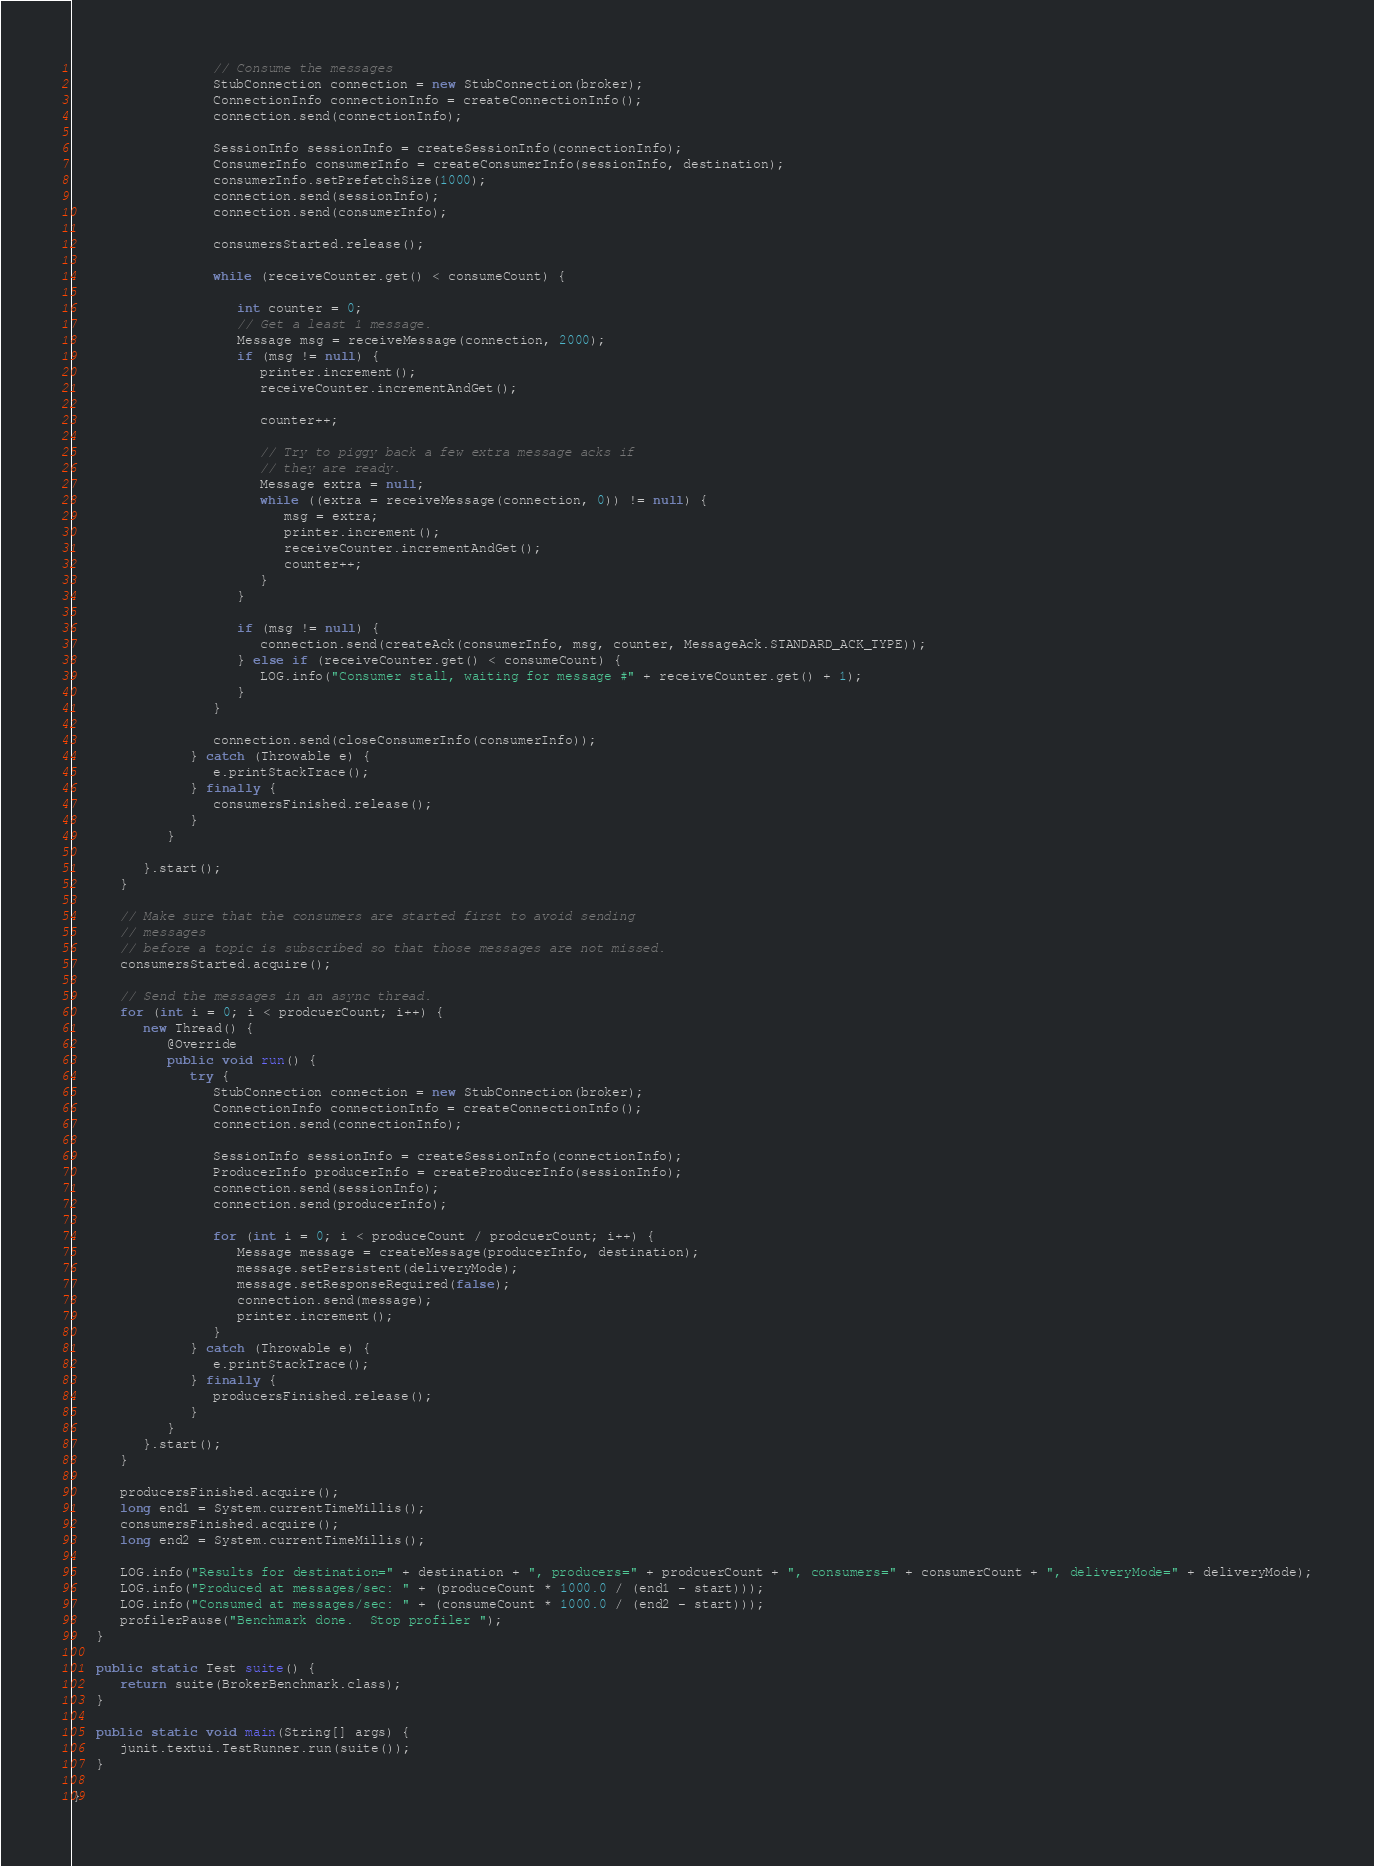<code> <loc_0><loc_0><loc_500><loc_500><_Java_>
                  // Consume the messages
                  StubConnection connection = new StubConnection(broker);
                  ConnectionInfo connectionInfo = createConnectionInfo();
                  connection.send(connectionInfo);

                  SessionInfo sessionInfo = createSessionInfo(connectionInfo);
                  ConsumerInfo consumerInfo = createConsumerInfo(sessionInfo, destination);
                  consumerInfo.setPrefetchSize(1000);
                  connection.send(sessionInfo);
                  connection.send(consumerInfo);

                  consumersStarted.release();

                  while (receiveCounter.get() < consumeCount) {

                     int counter = 0;
                     // Get a least 1 message.
                     Message msg = receiveMessage(connection, 2000);
                     if (msg != null) {
                        printer.increment();
                        receiveCounter.incrementAndGet();

                        counter++;

                        // Try to piggy back a few extra message acks if
                        // they are ready.
                        Message extra = null;
                        while ((extra = receiveMessage(connection, 0)) != null) {
                           msg = extra;
                           printer.increment();
                           receiveCounter.incrementAndGet();
                           counter++;
                        }
                     }

                     if (msg != null) {
                        connection.send(createAck(consumerInfo, msg, counter, MessageAck.STANDARD_ACK_TYPE));
                     } else if (receiveCounter.get() < consumeCount) {
                        LOG.info("Consumer stall, waiting for message #" + receiveCounter.get() + 1);
                     }
                  }

                  connection.send(closeConsumerInfo(consumerInfo));
               } catch (Throwable e) {
                  e.printStackTrace();
               } finally {
                  consumersFinished.release();
               }
            }

         }.start();
      }

      // Make sure that the consumers are started first to avoid sending
      // messages
      // before a topic is subscribed so that those messages are not missed.
      consumersStarted.acquire();

      // Send the messages in an async thread.
      for (int i = 0; i < prodcuerCount; i++) {
         new Thread() {
            @Override
            public void run() {
               try {
                  StubConnection connection = new StubConnection(broker);
                  ConnectionInfo connectionInfo = createConnectionInfo();
                  connection.send(connectionInfo);

                  SessionInfo sessionInfo = createSessionInfo(connectionInfo);
                  ProducerInfo producerInfo = createProducerInfo(sessionInfo);
                  connection.send(sessionInfo);
                  connection.send(producerInfo);

                  for (int i = 0; i < produceCount / prodcuerCount; i++) {
                     Message message = createMessage(producerInfo, destination);
                     message.setPersistent(deliveryMode);
                     message.setResponseRequired(false);
                     connection.send(message);
                     printer.increment();
                  }
               } catch (Throwable e) {
                  e.printStackTrace();
               } finally {
                  producersFinished.release();
               }
            }
         }.start();
      }

      producersFinished.acquire();
      long end1 = System.currentTimeMillis();
      consumersFinished.acquire();
      long end2 = System.currentTimeMillis();

      LOG.info("Results for destination=" + destination + ", producers=" + prodcuerCount + ", consumers=" + consumerCount + ", deliveryMode=" + deliveryMode);
      LOG.info("Produced at messages/sec: " + (produceCount * 1000.0 / (end1 - start)));
      LOG.info("Consumed at messages/sec: " + (consumeCount * 1000.0 / (end2 - start)));
      profilerPause("Benchmark done.  Stop profiler ");
   }

   public static Test suite() {
      return suite(BrokerBenchmark.class);
   }

   public static void main(String[] args) {
      junit.textui.TestRunner.run(suite());
   }

}
</code> 